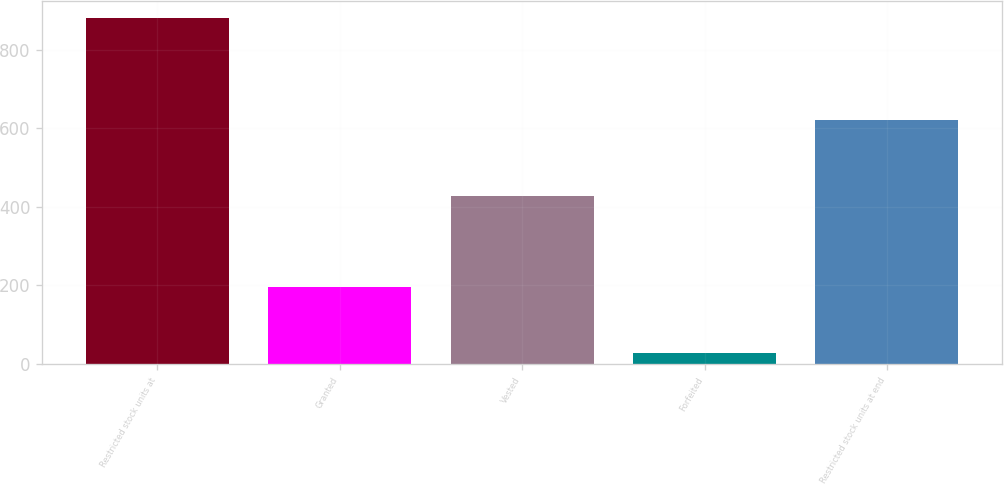<chart> <loc_0><loc_0><loc_500><loc_500><bar_chart><fcel>Restricted stock units at<fcel>Granted<fcel>Vested<fcel>Forfeited<fcel>Restricted stock units at end<nl><fcel>880<fcel>195<fcel>427<fcel>28<fcel>620<nl></chart> 